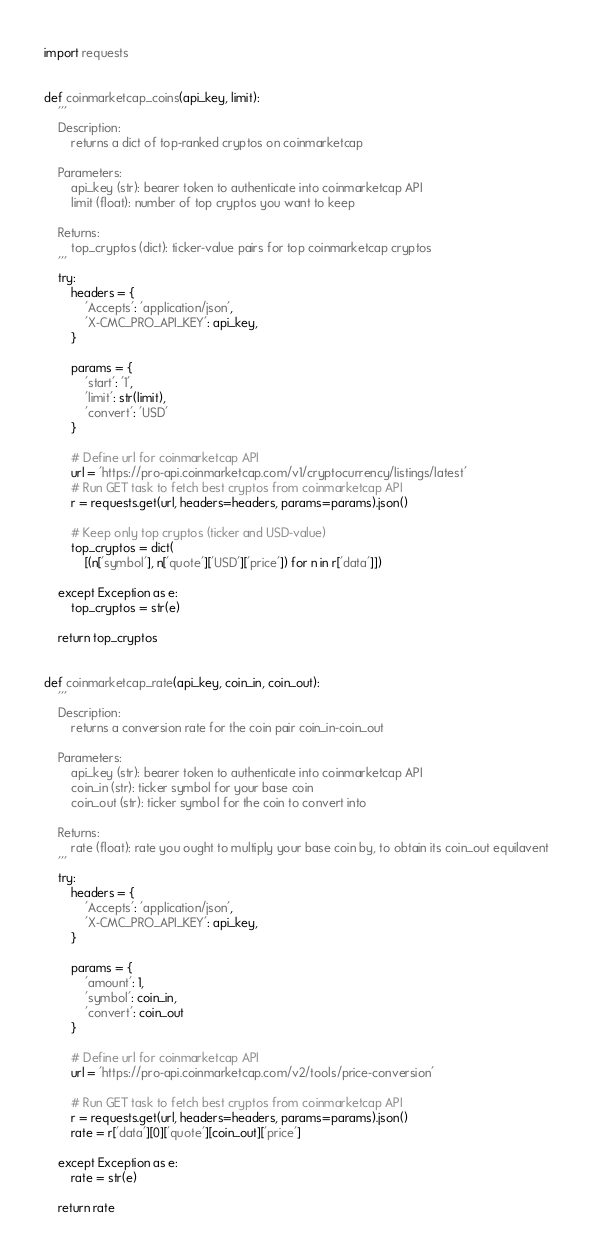Convert code to text. <code><loc_0><loc_0><loc_500><loc_500><_Python_>import requests


def coinmarketcap_coins(api_key, limit):
    '''
    Description:
        returns a dict of top-ranked cryptos on coinmarketcap

    Parameters:
        api_key (str): bearer token to authenticate into coinmarketcap API
        limit (float): number of top cryptos you want to keep

    Returns:
        top_cryptos (dict): ticker-value pairs for top coinmarketcap cryptos
    '''
    try:
        headers = {
            'Accepts': 'application/json',
            'X-CMC_PRO_API_KEY': api_key,
        }

        params = {
            'start': '1',
            'limit': str(limit),
            'convert': 'USD'
        }

        # Define url for coinmarketcap API
        url = 'https://pro-api.coinmarketcap.com/v1/cryptocurrency/listings/latest'
        # Run GET task to fetch best cryptos from coinmarketcap API
        r = requests.get(url, headers=headers, params=params).json()

        # Keep only top cryptos (ticker and USD-value)
        top_cryptos = dict(
            [(n['symbol'], n['quote']['USD']['price']) for n in r['data']])

    except Exception as e:
        top_cryptos = str(e)

    return top_cryptos


def coinmarketcap_rate(api_key, coin_in, coin_out):
    '''
    Description:
        returns a conversion rate for the coin pair coin_in-coin_out

    Parameters:
        api_key (str): bearer token to authenticate into coinmarketcap API
        coin_in (str): ticker symbol for your base coin
        coin_out (str): ticker symbol for the coin to convert into

    Returns:
        rate (float): rate you ought to multiply your base coin by, to obtain its coin_out equilavent
    '''
    try:
        headers = {
            'Accepts': 'application/json',
            'X-CMC_PRO_API_KEY': api_key,
        }

        params = {
            'amount': 1,
            'symbol': coin_in,
            'convert': coin_out
        }

        # Define url for coinmarketcap API
        url = 'https://pro-api.coinmarketcap.com/v2/tools/price-conversion'

        # Run GET task to fetch best cryptos from coinmarketcap API
        r = requests.get(url, headers=headers, params=params).json()
        rate = r['data'][0]['quote'][coin_out]['price']

    except Exception as e:
        rate = str(e)

    return rate
</code> 